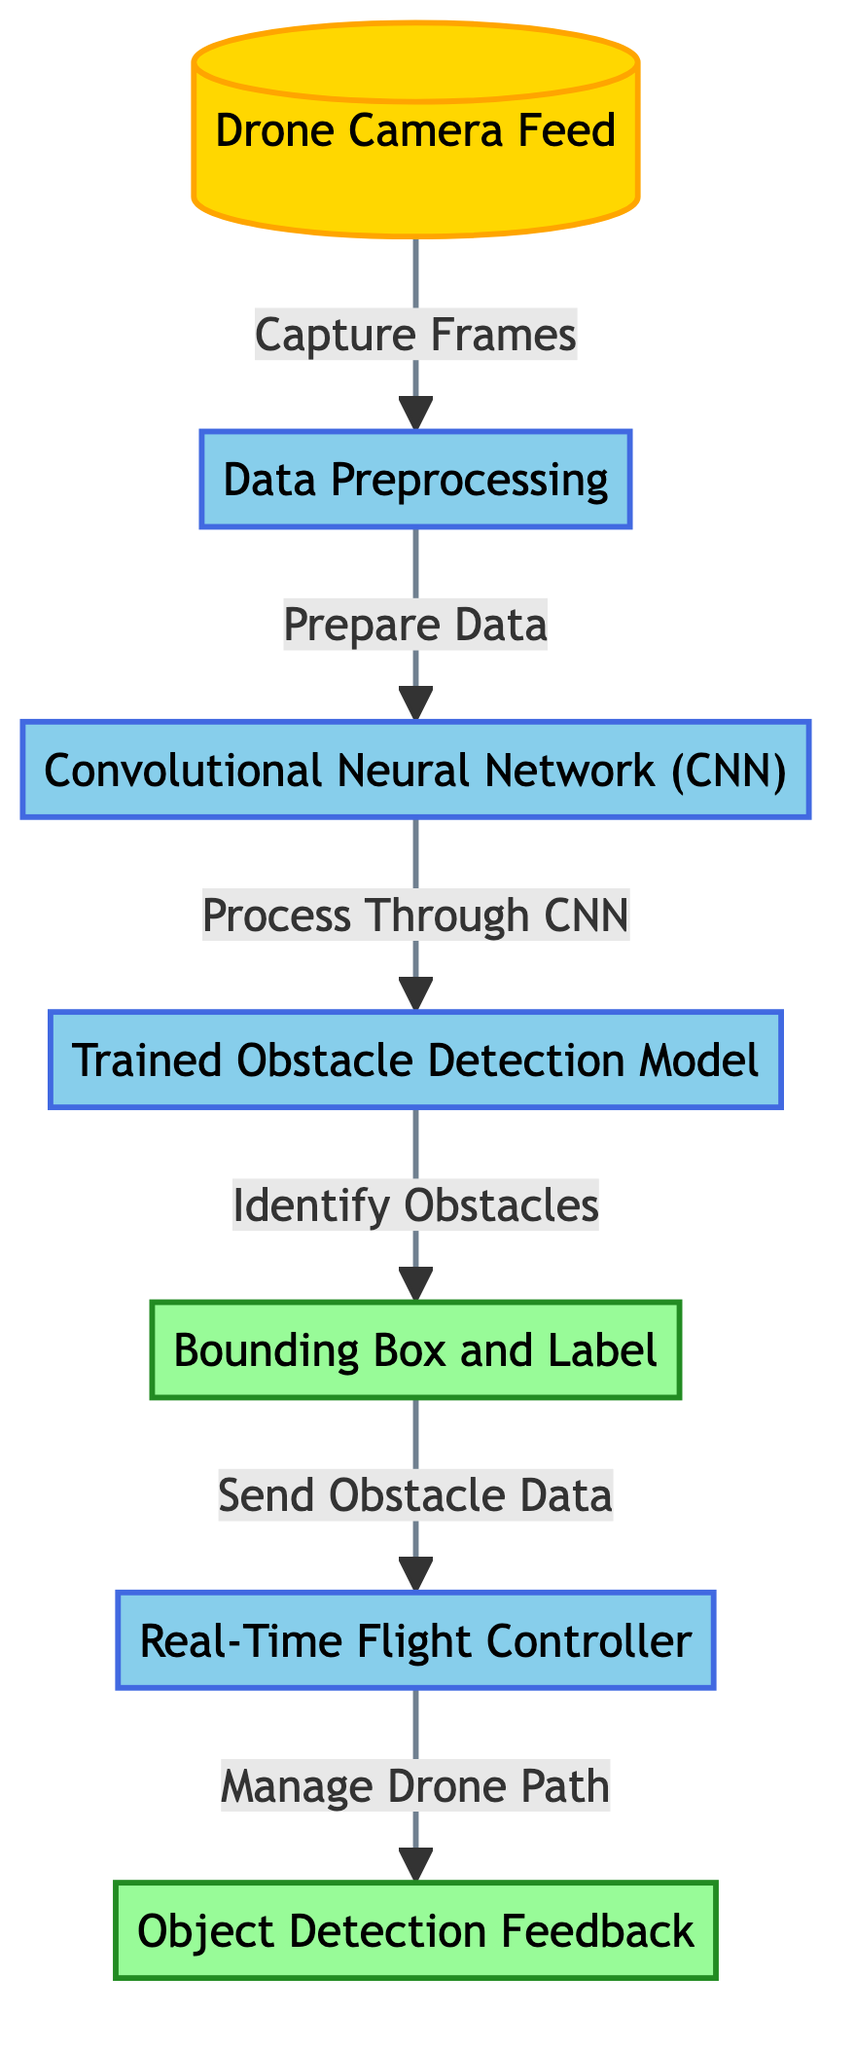What is the first step in the diagram? The first step is the "Drone Camera Feed," which is the source of input data captured by the drone.
Answer: Drone Camera Feed How many processes are present in this diagram? The diagram includes five process nodes, which are Data Preprocessing, Convolutional Neural Network (CNN), Trained Obstacle Detection Model, Real-Time Flight Controller, and Object Detection Feedback.
Answer: Five What does the "Data Preprocessing" node do? This node prepares the data for analysis, ensuring it is formatted and cleaned before it is processed by the CNN.
Answer: Prepare Data What is the relationship between "Bounding Box and Label" and "Real-Time Flight Controller"? The relationship is that the "Bounding Box and Label," which is output from the obstacle detection model, sends obstacle data to the "Real-Time Flight Controller" for managing the drone's path.
Answer: Sends Obstacle Data What is the output of the "Trained Obstacle Detection Model"? The output of the "Trained Obstacle Detection Model" is the "Bounding Box and Label," which provides information on identified obstacles.
Answer: Bounding Box and Label Which component directly manages drone navigation? The "Real-Time Flight Controller" is responsible for managing the drone's navigation based on the recognition of obstacles.
Answer: Real-Time Flight Controller How does the "Convolutional Neural Network (CNN)" contribute to the process? The CNN processes the prepared data, which helps in identifying the obstacles present in the camera feed.
Answer: Process Through CNN What feedback is generated after the "Real-Time Flight Controller" operates? The feedback generated is the "Object Detection Feedback," which helps inform the drone's operations based on the obstacle data received.
Answer: Object Detection Feedback What type of output is produced after identifying obstacles? The output produced is a "Bounding Box and Label," which visually indicates where the obstacles are within the camera feed.
Answer: Bounding Box and Label 